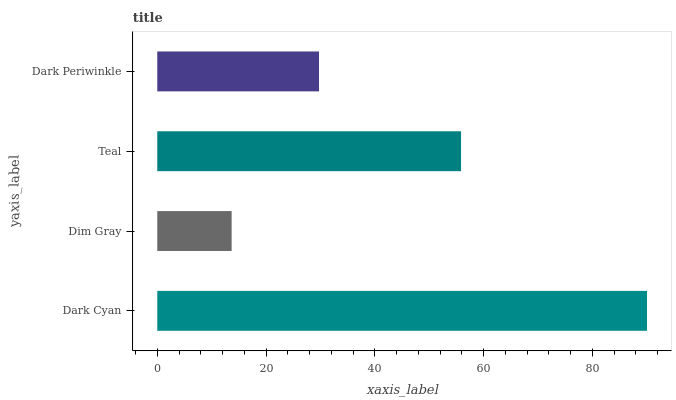Is Dim Gray the minimum?
Answer yes or no. Yes. Is Dark Cyan the maximum?
Answer yes or no. Yes. Is Teal the minimum?
Answer yes or no. No. Is Teal the maximum?
Answer yes or no. No. Is Teal greater than Dim Gray?
Answer yes or no. Yes. Is Dim Gray less than Teal?
Answer yes or no. Yes. Is Dim Gray greater than Teal?
Answer yes or no. No. Is Teal less than Dim Gray?
Answer yes or no. No. Is Teal the high median?
Answer yes or no. Yes. Is Dark Periwinkle the low median?
Answer yes or no. Yes. Is Dim Gray the high median?
Answer yes or no. No. Is Dim Gray the low median?
Answer yes or no. No. 